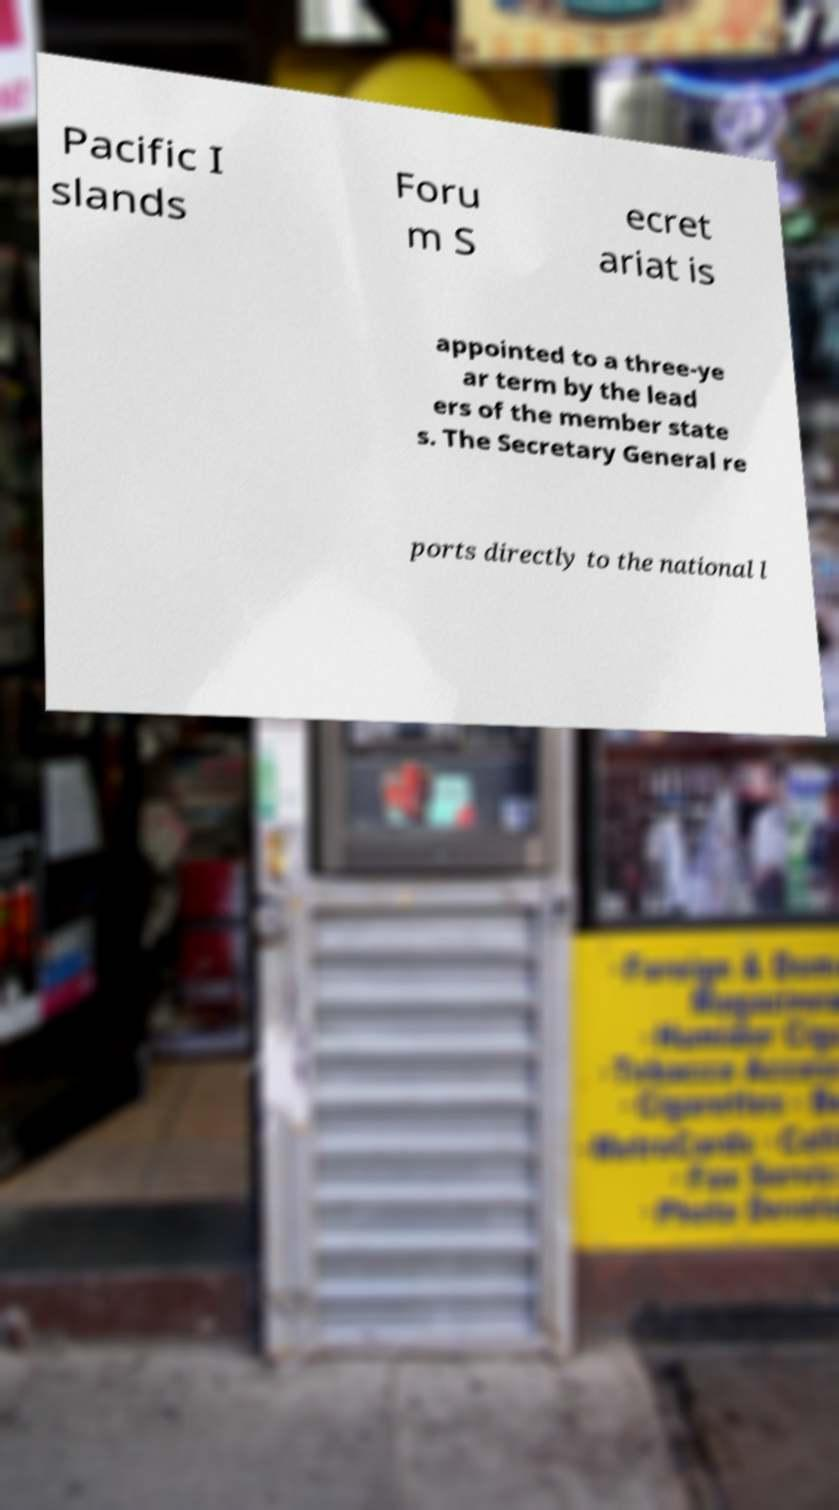Can you read and provide the text displayed in the image?This photo seems to have some interesting text. Can you extract and type it out for me? Pacific I slands Foru m S ecret ariat is appointed to a three-ye ar term by the lead ers of the member state s. The Secretary General re ports directly to the national l 